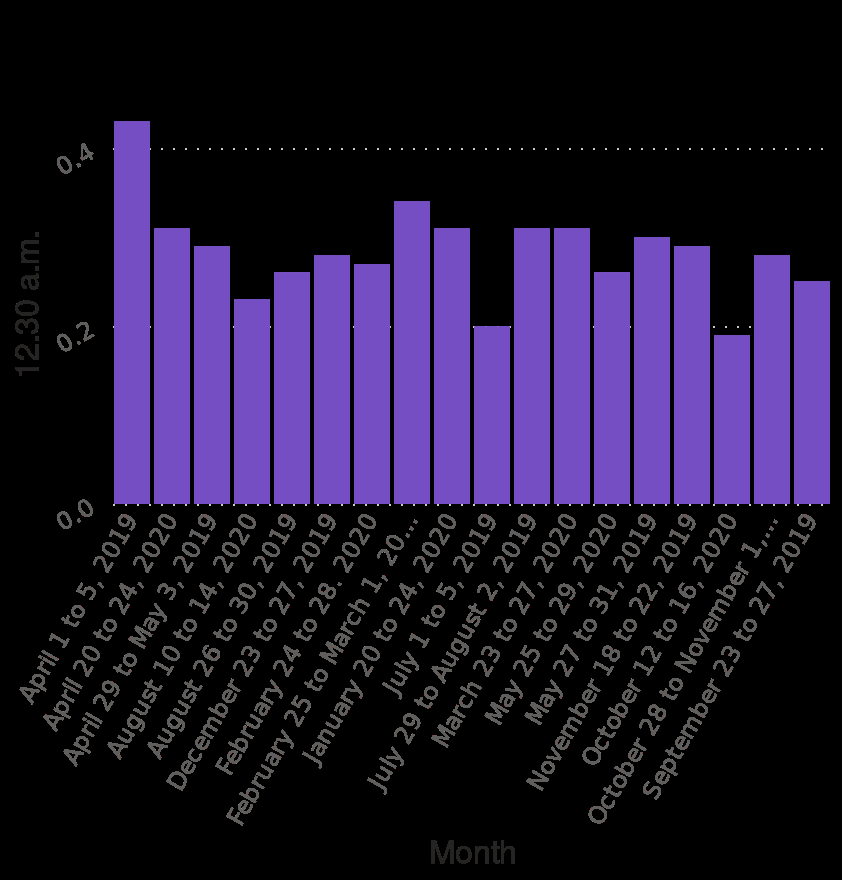<image>
Which period had the highest TV ratings? The period with the highest TV ratings was from April 1st to 5th, 2019. 